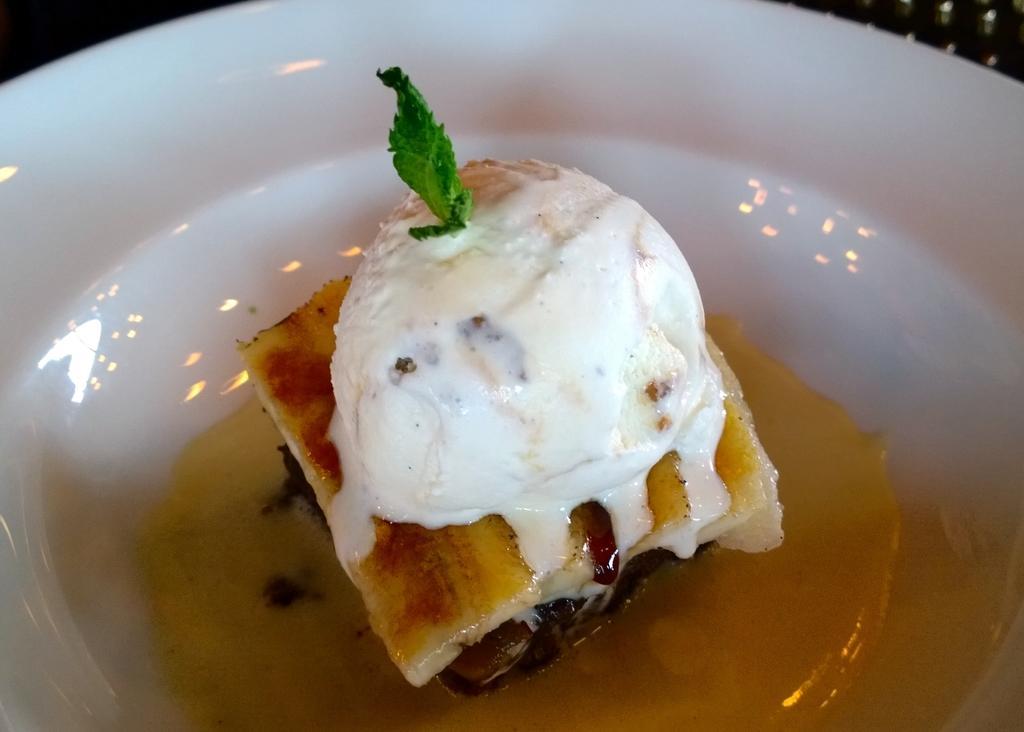Can you describe this image briefly? In the center of the image we can see one bowl. In the bowl, we can see one mint leaf, ice cream and some food items. In the background we can see a few other objects. 